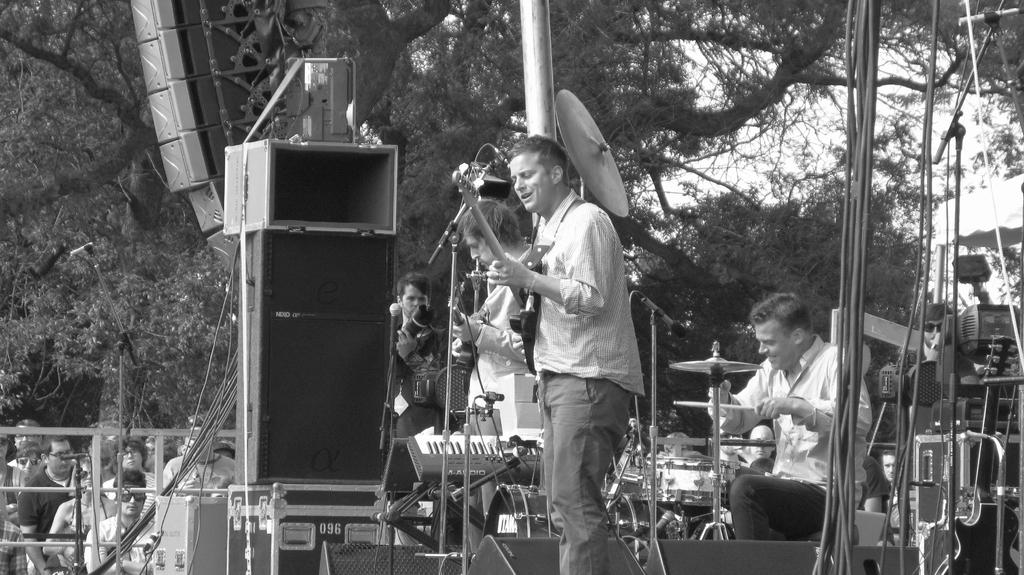What is the color scheme of the image? The image is black and white. What are the four persons in the image doing? They are playing musical instruments. Are there any spectators in the image? Yes, there are people watching the musicians. What can be seen in the background of the image? There is a big tree in the background of the image. What type of beef is being smashed by the musicians in the image? There is no beef or smashing activity present in the image. The musicians are playing musical instruments, and there is a big tree in the background. 